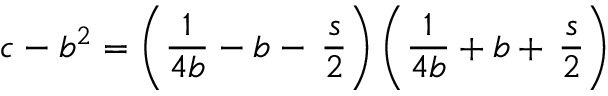Convert formula to latex. <formula><loc_0><loc_0><loc_500><loc_500>c - b ^ { 2 } = \left ( { \frac { 1 } { 4 b } } - b - \, \frac { s } { 2 } \right ) \left ( { \frac { 1 } { 4 b } } + b + \, \frac { s } { 2 } \right )</formula> 